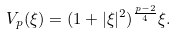Convert formula to latex. <formula><loc_0><loc_0><loc_500><loc_500>V _ { p } ( \xi ) = ( 1 + | \xi | ^ { 2 } ) ^ { \frac { p - 2 } { 4 } } \xi .</formula> 